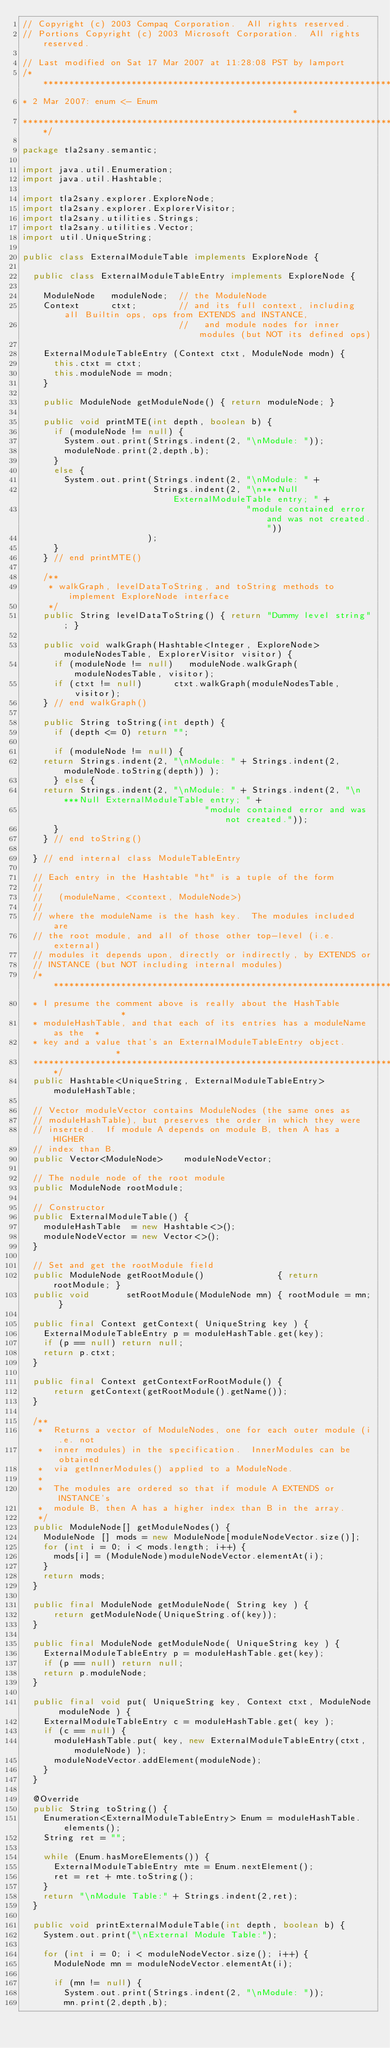Convert code to text. <code><loc_0><loc_0><loc_500><loc_500><_Java_>// Copyright (c) 2003 Compaq Corporation.  All rights reserved.
// Portions Copyright (c) 2003 Microsoft Corporation.  All rights reserved.

// Last modified on Sat 17 Mar 2007 at 11:28:08 PST by lamport
/***************************************************************************
* 2 Mar 2007: enum <- Enum                                                 *
***************************************************************************/

package tla2sany.semantic;

import java.util.Enumeration;
import java.util.Hashtable;

import tla2sany.explorer.ExploreNode;
import tla2sany.explorer.ExplorerVisitor;
import tla2sany.utilities.Strings;
import tla2sany.utilities.Vector;
import util.UniqueString;

public class ExternalModuleTable implements ExploreNode {

  public class ExternalModuleTableEntry implements ExploreNode {

    ModuleNode   moduleNode;  // the ModuleNode
    Context      ctxt;        // and its full context, including all Builtin ops, ops from EXTENDS and INSTANCE,
                              //   and module nodes for inner modules (but NOT its defined ops)

    ExternalModuleTableEntry (Context ctxt, ModuleNode modn) {
      this.ctxt = ctxt;
      this.moduleNode = modn;
    } 

    public ModuleNode getModuleNode() { return moduleNode; }

    public void printMTE(int depth, boolean b) {
      if (moduleNode != null) {
        System.out.print(Strings.indent(2, "\nModule: ")); 
        moduleNode.print(2,depth,b);
      }
      else {
        System.out.print(Strings.indent(2, "\nModule: " + 
                         Strings.indent(2, "\n***Null ExternalModuleTable entry; " + 
                                           "module contained error and was not created."))
                        );
      }
    } // end printMTE()

    /**  
     * walkGraph, levelDataToString, and toString methods to implement ExploreNode interface
     */
    public String levelDataToString() { return "Dummy level string"; }

    public void walkGraph(Hashtable<Integer, ExploreNode> moduleNodesTable, ExplorerVisitor visitor) {
      if (moduleNode != null)   moduleNode.walkGraph(moduleNodesTable, visitor);
      if (ctxt != null)      ctxt.walkGraph(moduleNodesTable, visitor);
    } // end walkGraph()

    public String toString(int depth) {
      if (depth <= 0) return "";
      
      if (moduleNode != null) {
	return Strings.indent(2, "\nModule: " + Strings.indent(2,moduleNode.toString(depth)) );
      } else {
	return Strings.indent(2, "\nModule: " + Strings.indent(2, "\n***Null ExternalModuleTable entry; " + 
							       "module contained error and was not created."));
      }
    } // end toString()

  } // end internal class ModuleTableEntry

  // Each entry in the Hashtable "ht" is a tuple of the form
  //
  //   (moduleName, <context, ModuleNode>)
  //
  // where the moduleName is the hash key.  The modules included are
  // the root module, and all of those other top-level (i.e. external)
  // modules it depends upon, directly or indirectly, by EXTENDS or
  // INSTANCE (but NOT including internal modules)
  /*************************************************************************
  * I presume the comment above is really about the HashTable              *
  * moduleHashTable, and that each of its entries has a moduleName as the  *
  * key and a value that's an ExternalModuleTableEntry object.             *
  *************************************************************************/
  public Hashtable<UniqueString, ExternalModuleTableEntry> moduleHashTable;

  // Vector moduleVector contains ModuleNodes (the same ones as
  // moduleHashTable), but preserves the order in which they were
  // inserted.  If module A depends on module B, then A has a HIGHER
  // index than B.
  public Vector<ModuleNode>    moduleNodeVector;

  // The nodule node of the root module
  public ModuleNode rootModule;

  // Constructor
  public ExternalModuleTable() {
    moduleHashTable  = new Hashtable<>();
    moduleNodeVector = new Vector<>();
  }

  // Set and get the rootModule field
  public ModuleNode getRootModule()              { return rootModule; }
  public void       setRootModule(ModuleNode mn) { rootModule = mn; }

  public final Context getContext( UniqueString key ) {
    ExternalModuleTableEntry p = moduleHashTable.get(key);
    if (p == null) return null;
    return p.ctxt;
  }

  public final Context getContextForRootModule() {
	  return getContext(getRootModule().getName());
  }
  
  /**
   *  Returns a vector of ModuleNodes, one for each outer module (i.e. not
   *  inner modules) in the specification.  InnerModules can be obtained 
   *  via getInnerModules() applied to a ModuleNode.
   *
   *  The modules are ordered so that if module A EXTENDS or INSTANCE's
   *  module B, then A has a higher index than B in the array.
   */
  public ModuleNode[] getModuleNodes() {
    ModuleNode [] mods = new ModuleNode[moduleNodeVector.size()];
    for (int i = 0; i < mods.length; i++) {
      mods[i] = (ModuleNode)moduleNodeVector.elementAt(i);
    }
    return mods;
  }

  public final ModuleNode getModuleNode( String key ) {
	  return getModuleNode(UniqueString.of(key));
  }

  public final ModuleNode getModuleNode( UniqueString key ) {
    ExternalModuleTableEntry p = moduleHashTable.get(key);
    if (p == null) return null;
    return p.moduleNode;
  }

  public final void put( UniqueString key, Context ctxt, ModuleNode moduleNode ) {
    ExternalModuleTableEntry c = moduleHashTable.get( key );
    if (c == null) {
      moduleHashTable.put( key, new ExternalModuleTableEntry(ctxt, moduleNode) );
      moduleNodeVector.addElement(moduleNode);
    }
  }

  @Override
  public String toString() {
    Enumeration<ExternalModuleTableEntry> Enum = moduleHashTable.elements();
    String ret = "";

    while (Enum.hasMoreElements()) {
      ExternalModuleTableEntry mte = Enum.nextElement();
      ret = ret + mte.toString();
    }
    return "\nModule Table:" + Strings.indent(2,ret);
  }

  public void printExternalModuleTable(int depth, boolean b) {
    System.out.print("\nExternal Module Table:");

    for (int i = 0; i < moduleNodeVector.size(); i++) {
      ModuleNode mn = moduleNodeVector.elementAt(i);

      if (mn != null) {
        System.out.print(Strings.indent(2, "\nModule: ")); 
        mn.print(2,depth,b);</code> 